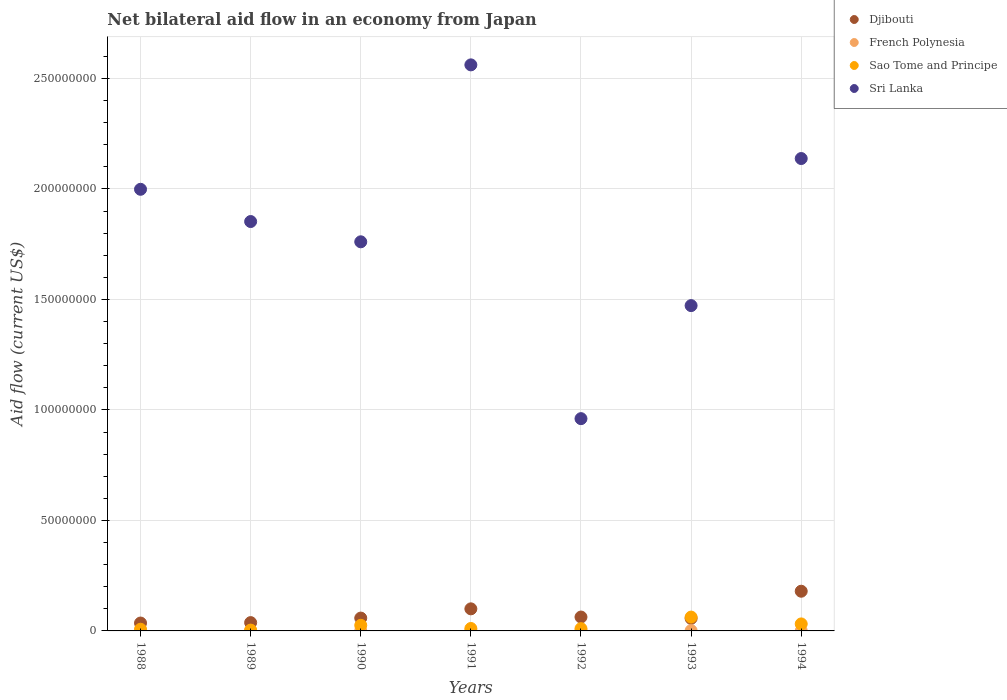Is the number of dotlines equal to the number of legend labels?
Provide a succinct answer. Yes. Across all years, what is the maximum net bilateral aid flow in Djibouti?
Give a very brief answer. 1.80e+07. Across all years, what is the minimum net bilateral aid flow in Sao Tome and Principe?
Offer a terse response. 3.70e+05. What is the total net bilateral aid flow in Sao Tome and Principe in the graph?
Keep it short and to the point. 1.52e+07. What is the difference between the net bilateral aid flow in Djibouti in 1989 and that in 1990?
Your answer should be very brief. -2.05e+06. What is the difference between the net bilateral aid flow in Djibouti in 1991 and the net bilateral aid flow in Sri Lanka in 1992?
Give a very brief answer. -8.61e+07. What is the average net bilateral aid flow in French Polynesia per year?
Keep it short and to the point. 1.13e+05. In the year 1988, what is the difference between the net bilateral aid flow in Sao Tome and Principe and net bilateral aid flow in French Polynesia?
Provide a short and direct response. 7.20e+05. In how many years, is the net bilateral aid flow in Sri Lanka greater than 160000000 US$?
Make the answer very short. 5. What is the ratio of the net bilateral aid flow in Sao Tome and Principe in 1988 to that in 1992?
Offer a terse response. 0.74. Is the difference between the net bilateral aid flow in Sao Tome and Principe in 1991 and 1994 greater than the difference between the net bilateral aid flow in French Polynesia in 1991 and 1994?
Offer a terse response. No. What is the difference between the highest and the second highest net bilateral aid flow in Sao Tome and Principe?
Provide a short and direct response. 3.09e+06. What is the difference between the highest and the lowest net bilateral aid flow in Djibouti?
Provide a succinct answer. 1.44e+07. Is it the case that in every year, the sum of the net bilateral aid flow in Sri Lanka and net bilateral aid flow in Sao Tome and Principe  is greater than the sum of net bilateral aid flow in Djibouti and net bilateral aid flow in French Polynesia?
Give a very brief answer. Yes. Is it the case that in every year, the sum of the net bilateral aid flow in Sri Lanka and net bilateral aid flow in French Polynesia  is greater than the net bilateral aid flow in Sao Tome and Principe?
Ensure brevity in your answer.  Yes. Is the net bilateral aid flow in Djibouti strictly greater than the net bilateral aid flow in French Polynesia over the years?
Give a very brief answer. Yes. How many dotlines are there?
Keep it short and to the point. 4. Are the values on the major ticks of Y-axis written in scientific E-notation?
Provide a short and direct response. No. Where does the legend appear in the graph?
Your answer should be very brief. Top right. How many legend labels are there?
Offer a very short reply. 4. What is the title of the graph?
Your response must be concise. Net bilateral aid flow in an economy from Japan. Does "Bulgaria" appear as one of the legend labels in the graph?
Offer a very short reply. No. What is the label or title of the Y-axis?
Your answer should be compact. Aid flow (current US$). What is the Aid flow (current US$) of Djibouti in 1988?
Ensure brevity in your answer.  3.57e+06. What is the Aid flow (current US$) in French Polynesia in 1988?
Make the answer very short. 4.00e+04. What is the Aid flow (current US$) of Sao Tome and Principe in 1988?
Your answer should be very brief. 7.60e+05. What is the Aid flow (current US$) of Sri Lanka in 1988?
Keep it short and to the point. 2.00e+08. What is the Aid flow (current US$) in Djibouti in 1989?
Keep it short and to the point. 3.76e+06. What is the Aid flow (current US$) in French Polynesia in 1989?
Give a very brief answer. 1.40e+05. What is the Aid flow (current US$) in Sao Tome and Principe in 1989?
Ensure brevity in your answer.  3.70e+05. What is the Aid flow (current US$) of Sri Lanka in 1989?
Your response must be concise. 1.85e+08. What is the Aid flow (current US$) of Djibouti in 1990?
Your answer should be compact. 5.81e+06. What is the Aid flow (current US$) in French Polynesia in 1990?
Keep it short and to the point. 1.00e+05. What is the Aid flow (current US$) in Sao Tome and Principe in 1990?
Keep it short and to the point. 2.54e+06. What is the Aid flow (current US$) of Sri Lanka in 1990?
Give a very brief answer. 1.76e+08. What is the Aid flow (current US$) in Djibouti in 1991?
Ensure brevity in your answer.  9.99e+06. What is the Aid flow (current US$) of French Polynesia in 1991?
Give a very brief answer. 1.40e+05. What is the Aid flow (current US$) of Sao Tome and Principe in 1991?
Your response must be concise. 1.10e+06. What is the Aid flow (current US$) in Sri Lanka in 1991?
Make the answer very short. 2.56e+08. What is the Aid flow (current US$) of Djibouti in 1992?
Keep it short and to the point. 6.28e+06. What is the Aid flow (current US$) in Sao Tome and Principe in 1992?
Offer a terse response. 1.03e+06. What is the Aid flow (current US$) in Sri Lanka in 1992?
Provide a succinct answer. 9.60e+07. What is the Aid flow (current US$) of Djibouti in 1993?
Give a very brief answer. 5.67e+06. What is the Aid flow (current US$) of French Polynesia in 1993?
Give a very brief answer. 1.40e+05. What is the Aid flow (current US$) in Sao Tome and Principe in 1993?
Provide a succinct answer. 6.26e+06. What is the Aid flow (current US$) of Sri Lanka in 1993?
Your response must be concise. 1.47e+08. What is the Aid flow (current US$) in Djibouti in 1994?
Give a very brief answer. 1.80e+07. What is the Aid flow (current US$) of Sao Tome and Principe in 1994?
Provide a succinct answer. 3.17e+06. What is the Aid flow (current US$) of Sri Lanka in 1994?
Provide a short and direct response. 2.14e+08. Across all years, what is the maximum Aid flow (current US$) in Djibouti?
Give a very brief answer. 1.80e+07. Across all years, what is the maximum Aid flow (current US$) of French Polynesia?
Ensure brevity in your answer.  1.70e+05. Across all years, what is the maximum Aid flow (current US$) of Sao Tome and Principe?
Your response must be concise. 6.26e+06. Across all years, what is the maximum Aid flow (current US$) in Sri Lanka?
Keep it short and to the point. 2.56e+08. Across all years, what is the minimum Aid flow (current US$) in Djibouti?
Offer a very short reply. 3.57e+06. Across all years, what is the minimum Aid flow (current US$) in French Polynesia?
Your response must be concise. 4.00e+04. Across all years, what is the minimum Aid flow (current US$) in Sao Tome and Principe?
Your response must be concise. 3.70e+05. Across all years, what is the minimum Aid flow (current US$) in Sri Lanka?
Your response must be concise. 9.60e+07. What is the total Aid flow (current US$) of Djibouti in the graph?
Your answer should be very brief. 5.30e+07. What is the total Aid flow (current US$) of French Polynesia in the graph?
Keep it short and to the point. 7.90e+05. What is the total Aid flow (current US$) in Sao Tome and Principe in the graph?
Offer a terse response. 1.52e+07. What is the total Aid flow (current US$) of Sri Lanka in the graph?
Offer a terse response. 1.27e+09. What is the difference between the Aid flow (current US$) of Djibouti in 1988 and that in 1989?
Ensure brevity in your answer.  -1.90e+05. What is the difference between the Aid flow (current US$) in Sri Lanka in 1988 and that in 1989?
Provide a short and direct response. 1.46e+07. What is the difference between the Aid flow (current US$) of Djibouti in 1988 and that in 1990?
Ensure brevity in your answer.  -2.24e+06. What is the difference between the Aid flow (current US$) of Sao Tome and Principe in 1988 and that in 1990?
Provide a short and direct response. -1.78e+06. What is the difference between the Aid flow (current US$) in Sri Lanka in 1988 and that in 1990?
Your answer should be compact. 2.38e+07. What is the difference between the Aid flow (current US$) in Djibouti in 1988 and that in 1991?
Offer a terse response. -6.42e+06. What is the difference between the Aid flow (current US$) of Sao Tome and Principe in 1988 and that in 1991?
Your answer should be compact. -3.40e+05. What is the difference between the Aid flow (current US$) of Sri Lanka in 1988 and that in 1991?
Your response must be concise. -5.63e+07. What is the difference between the Aid flow (current US$) in Djibouti in 1988 and that in 1992?
Provide a short and direct response. -2.71e+06. What is the difference between the Aid flow (current US$) in Sao Tome and Principe in 1988 and that in 1992?
Give a very brief answer. -2.70e+05. What is the difference between the Aid flow (current US$) of Sri Lanka in 1988 and that in 1992?
Your answer should be very brief. 1.04e+08. What is the difference between the Aid flow (current US$) of Djibouti in 1988 and that in 1993?
Provide a succinct answer. -2.10e+06. What is the difference between the Aid flow (current US$) in French Polynesia in 1988 and that in 1993?
Ensure brevity in your answer.  -1.00e+05. What is the difference between the Aid flow (current US$) in Sao Tome and Principe in 1988 and that in 1993?
Provide a succinct answer. -5.50e+06. What is the difference between the Aid flow (current US$) of Sri Lanka in 1988 and that in 1993?
Your answer should be compact. 5.26e+07. What is the difference between the Aid flow (current US$) of Djibouti in 1988 and that in 1994?
Your answer should be very brief. -1.44e+07. What is the difference between the Aid flow (current US$) in Sao Tome and Principe in 1988 and that in 1994?
Your response must be concise. -2.41e+06. What is the difference between the Aid flow (current US$) in Sri Lanka in 1988 and that in 1994?
Provide a succinct answer. -1.39e+07. What is the difference between the Aid flow (current US$) of Djibouti in 1989 and that in 1990?
Provide a short and direct response. -2.05e+06. What is the difference between the Aid flow (current US$) of French Polynesia in 1989 and that in 1990?
Make the answer very short. 4.00e+04. What is the difference between the Aid flow (current US$) in Sao Tome and Principe in 1989 and that in 1990?
Make the answer very short. -2.17e+06. What is the difference between the Aid flow (current US$) in Sri Lanka in 1989 and that in 1990?
Your answer should be very brief. 9.17e+06. What is the difference between the Aid flow (current US$) in Djibouti in 1989 and that in 1991?
Offer a very short reply. -6.23e+06. What is the difference between the Aid flow (current US$) in Sao Tome and Principe in 1989 and that in 1991?
Make the answer very short. -7.30e+05. What is the difference between the Aid flow (current US$) of Sri Lanka in 1989 and that in 1991?
Offer a terse response. -7.09e+07. What is the difference between the Aid flow (current US$) of Djibouti in 1989 and that in 1992?
Keep it short and to the point. -2.52e+06. What is the difference between the Aid flow (current US$) in Sao Tome and Principe in 1989 and that in 1992?
Keep it short and to the point. -6.60e+05. What is the difference between the Aid flow (current US$) in Sri Lanka in 1989 and that in 1992?
Keep it short and to the point. 8.92e+07. What is the difference between the Aid flow (current US$) of Djibouti in 1989 and that in 1993?
Offer a very short reply. -1.91e+06. What is the difference between the Aid flow (current US$) in French Polynesia in 1989 and that in 1993?
Make the answer very short. 0. What is the difference between the Aid flow (current US$) in Sao Tome and Principe in 1989 and that in 1993?
Ensure brevity in your answer.  -5.89e+06. What is the difference between the Aid flow (current US$) of Sri Lanka in 1989 and that in 1993?
Give a very brief answer. 3.80e+07. What is the difference between the Aid flow (current US$) of Djibouti in 1989 and that in 1994?
Your answer should be compact. -1.42e+07. What is the difference between the Aid flow (current US$) in Sao Tome and Principe in 1989 and that in 1994?
Keep it short and to the point. -2.80e+06. What is the difference between the Aid flow (current US$) of Sri Lanka in 1989 and that in 1994?
Ensure brevity in your answer.  -2.85e+07. What is the difference between the Aid flow (current US$) of Djibouti in 1990 and that in 1991?
Provide a succinct answer. -4.18e+06. What is the difference between the Aid flow (current US$) of Sao Tome and Principe in 1990 and that in 1991?
Your answer should be very brief. 1.44e+06. What is the difference between the Aid flow (current US$) in Sri Lanka in 1990 and that in 1991?
Your answer should be compact. -8.01e+07. What is the difference between the Aid flow (current US$) in Djibouti in 1990 and that in 1992?
Make the answer very short. -4.70e+05. What is the difference between the Aid flow (current US$) in French Polynesia in 1990 and that in 1992?
Provide a succinct answer. -7.00e+04. What is the difference between the Aid flow (current US$) of Sao Tome and Principe in 1990 and that in 1992?
Your response must be concise. 1.51e+06. What is the difference between the Aid flow (current US$) in Sri Lanka in 1990 and that in 1992?
Your answer should be compact. 8.00e+07. What is the difference between the Aid flow (current US$) in Djibouti in 1990 and that in 1993?
Give a very brief answer. 1.40e+05. What is the difference between the Aid flow (current US$) in Sao Tome and Principe in 1990 and that in 1993?
Your answer should be compact. -3.72e+06. What is the difference between the Aid flow (current US$) in Sri Lanka in 1990 and that in 1993?
Your answer should be very brief. 2.89e+07. What is the difference between the Aid flow (current US$) of Djibouti in 1990 and that in 1994?
Offer a very short reply. -1.22e+07. What is the difference between the Aid flow (current US$) of French Polynesia in 1990 and that in 1994?
Keep it short and to the point. 4.00e+04. What is the difference between the Aid flow (current US$) of Sao Tome and Principe in 1990 and that in 1994?
Offer a terse response. -6.30e+05. What is the difference between the Aid flow (current US$) of Sri Lanka in 1990 and that in 1994?
Offer a terse response. -3.77e+07. What is the difference between the Aid flow (current US$) in Djibouti in 1991 and that in 1992?
Your answer should be compact. 3.71e+06. What is the difference between the Aid flow (current US$) of French Polynesia in 1991 and that in 1992?
Ensure brevity in your answer.  -3.00e+04. What is the difference between the Aid flow (current US$) of Sao Tome and Principe in 1991 and that in 1992?
Ensure brevity in your answer.  7.00e+04. What is the difference between the Aid flow (current US$) of Sri Lanka in 1991 and that in 1992?
Your answer should be compact. 1.60e+08. What is the difference between the Aid flow (current US$) in Djibouti in 1991 and that in 1993?
Keep it short and to the point. 4.32e+06. What is the difference between the Aid flow (current US$) of Sao Tome and Principe in 1991 and that in 1993?
Make the answer very short. -5.16e+06. What is the difference between the Aid flow (current US$) of Sri Lanka in 1991 and that in 1993?
Make the answer very short. 1.09e+08. What is the difference between the Aid flow (current US$) in Djibouti in 1991 and that in 1994?
Keep it short and to the point. -7.97e+06. What is the difference between the Aid flow (current US$) of Sao Tome and Principe in 1991 and that in 1994?
Your answer should be compact. -2.07e+06. What is the difference between the Aid flow (current US$) in Sri Lanka in 1991 and that in 1994?
Your answer should be very brief. 4.24e+07. What is the difference between the Aid flow (current US$) of Djibouti in 1992 and that in 1993?
Keep it short and to the point. 6.10e+05. What is the difference between the Aid flow (current US$) in Sao Tome and Principe in 1992 and that in 1993?
Offer a very short reply. -5.23e+06. What is the difference between the Aid flow (current US$) of Sri Lanka in 1992 and that in 1993?
Ensure brevity in your answer.  -5.12e+07. What is the difference between the Aid flow (current US$) of Djibouti in 1992 and that in 1994?
Your response must be concise. -1.17e+07. What is the difference between the Aid flow (current US$) of Sao Tome and Principe in 1992 and that in 1994?
Keep it short and to the point. -2.14e+06. What is the difference between the Aid flow (current US$) in Sri Lanka in 1992 and that in 1994?
Give a very brief answer. -1.18e+08. What is the difference between the Aid flow (current US$) in Djibouti in 1993 and that in 1994?
Give a very brief answer. -1.23e+07. What is the difference between the Aid flow (current US$) of French Polynesia in 1993 and that in 1994?
Ensure brevity in your answer.  8.00e+04. What is the difference between the Aid flow (current US$) in Sao Tome and Principe in 1993 and that in 1994?
Keep it short and to the point. 3.09e+06. What is the difference between the Aid flow (current US$) of Sri Lanka in 1993 and that in 1994?
Provide a short and direct response. -6.66e+07. What is the difference between the Aid flow (current US$) in Djibouti in 1988 and the Aid flow (current US$) in French Polynesia in 1989?
Ensure brevity in your answer.  3.43e+06. What is the difference between the Aid flow (current US$) of Djibouti in 1988 and the Aid flow (current US$) of Sao Tome and Principe in 1989?
Provide a succinct answer. 3.20e+06. What is the difference between the Aid flow (current US$) of Djibouti in 1988 and the Aid flow (current US$) of Sri Lanka in 1989?
Make the answer very short. -1.82e+08. What is the difference between the Aid flow (current US$) in French Polynesia in 1988 and the Aid flow (current US$) in Sao Tome and Principe in 1989?
Ensure brevity in your answer.  -3.30e+05. What is the difference between the Aid flow (current US$) of French Polynesia in 1988 and the Aid flow (current US$) of Sri Lanka in 1989?
Offer a terse response. -1.85e+08. What is the difference between the Aid flow (current US$) of Sao Tome and Principe in 1988 and the Aid flow (current US$) of Sri Lanka in 1989?
Offer a very short reply. -1.84e+08. What is the difference between the Aid flow (current US$) in Djibouti in 1988 and the Aid flow (current US$) in French Polynesia in 1990?
Offer a terse response. 3.47e+06. What is the difference between the Aid flow (current US$) in Djibouti in 1988 and the Aid flow (current US$) in Sao Tome and Principe in 1990?
Provide a short and direct response. 1.03e+06. What is the difference between the Aid flow (current US$) in Djibouti in 1988 and the Aid flow (current US$) in Sri Lanka in 1990?
Your answer should be very brief. -1.72e+08. What is the difference between the Aid flow (current US$) in French Polynesia in 1988 and the Aid flow (current US$) in Sao Tome and Principe in 1990?
Offer a very short reply. -2.50e+06. What is the difference between the Aid flow (current US$) of French Polynesia in 1988 and the Aid flow (current US$) of Sri Lanka in 1990?
Your answer should be compact. -1.76e+08. What is the difference between the Aid flow (current US$) in Sao Tome and Principe in 1988 and the Aid flow (current US$) in Sri Lanka in 1990?
Offer a very short reply. -1.75e+08. What is the difference between the Aid flow (current US$) of Djibouti in 1988 and the Aid flow (current US$) of French Polynesia in 1991?
Give a very brief answer. 3.43e+06. What is the difference between the Aid flow (current US$) in Djibouti in 1988 and the Aid flow (current US$) in Sao Tome and Principe in 1991?
Offer a terse response. 2.47e+06. What is the difference between the Aid flow (current US$) of Djibouti in 1988 and the Aid flow (current US$) of Sri Lanka in 1991?
Give a very brief answer. -2.53e+08. What is the difference between the Aid flow (current US$) of French Polynesia in 1988 and the Aid flow (current US$) of Sao Tome and Principe in 1991?
Your response must be concise. -1.06e+06. What is the difference between the Aid flow (current US$) in French Polynesia in 1988 and the Aid flow (current US$) in Sri Lanka in 1991?
Ensure brevity in your answer.  -2.56e+08. What is the difference between the Aid flow (current US$) of Sao Tome and Principe in 1988 and the Aid flow (current US$) of Sri Lanka in 1991?
Your response must be concise. -2.55e+08. What is the difference between the Aid flow (current US$) in Djibouti in 1988 and the Aid flow (current US$) in French Polynesia in 1992?
Ensure brevity in your answer.  3.40e+06. What is the difference between the Aid flow (current US$) of Djibouti in 1988 and the Aid flow (current US$) of Sao Tome and Principe in 1992?
Give a very brief answer. 2.54e+06. What is the difference between the Aid flow (current US$) of Djibouti in 1988 and the Aid flow (current US$) of Sri Lanka in 1992?
Provide a succinct answer. -9.25e+07. What is the difference between the Aid flow (current US$) of French Polynesia in 1988 and the Aid flow (current US$) of Sao Tome and Principe in 1992?
Offer a terse response. -9.90e+05. What is the difference between the Aid flow (current US$) in French Polynesia in 1988 and the Aid flow (current US$) in Sri Lanka in 1992?
Your response must be concise. -9.60e+07. What is the difference between the Aid flow (current US$) of Sao Tome and Principe in 1988 and the Aid flow (current US$) of Sri Lanka in 1992?
Your answer should be compact. -9.53e+07. What is the difference between the Aid flow (current US$) in Djibouti in 1988 and the Aid flow (current US$) in French Polynesia in 1993?
Make the answer very short. 3.43e+06. What is the difference between the Aid flow (current US$) in Djibouti in 1988 and the Aid flow (current US$) in Sao Tome and Principe in 1993?
Give a very brief answer. -2.69e+06. What is the difference between the Aid flow (current US$) in Djibouti in 1988 and the Aid flow (current US$) in Sri Lanka in 1993?
Provide a short and direct response. -1.44e+08. What is the difference between the Aid flow (current US$) of French Polynesia in 1988 and the Aid flow (current US$) of Sao Tome and Principe in 1993?
Your response must be concise. -6.22e+06. What is the difference between the Aid flow (current US$) in French Polynesia in 1988 and the Aid flow (current US$) in Sri Lanka in 1993?
Offer a terse response. -1.47e+08. What is the difference between the Aid flow (current US$) in Sao Tome and Principe in 1988 and the Aid flow (current US$) in Sri Lanka in 1993?
Offer a very short reply. -1.46e+08. What is the difference between the Aid flow (current US$) of Djibouti in 1988 and the Aid flow (current US$) of French Polynesia in 1994?
Keep it short and to the point. 3.51e+06. What is the difference between the Aid flow (current US$) in Djibouti in 1988 and the Aid flow (current US$) in Sri Lanka in 1994?
Your answer should be very brief. -2.10e+08. What is the difference between the Aid flow (current US$) of French Polynesia in 1988 and the Aid flow (current US$) of Sao Tome and Principe in 1994?
Provide a succinct answer. -3.13e+06. What is the difference between the Aid flow (current US$) in French Polynesia in 1988 and the Aid flow (current US$) in Sri Lanka in 1994?
Your answer should be very brief. -2.14e+08. What is the difference between the Aid flow (current US$) in Sao Tome and Principe in 1988 and the Aid flow (current US$) in Sri Lanka in 1994?
Your response must be concise. -2.13e+08. What is the difference between the Aid flow (current US$) in Djibouti in 1989 and the Aid flow (current US$) in French Polynesia in 1990?
Offer a terse response. 3.66e+06. What is the difference between the Aid flow (current US$) in Djibouti in 1989 and the Aid flow (current US$) in Sao Tome and Principe in 1990?
Give a very brief answer. 1.22e+06. What is the difference between the Aid flow (current US$) in Djibouti in 1989 and the Aid flow (current US$) in Sri Lanka in 1990?
Keep it short and to the point. -1.72e+08. What is the difference between the Aid flow (current US$) of French Polynesia in 1989 and the Aid flow (current US$) of Sao Tome and Principe in 1990?
Provide a succinct answer. -2.40e+06. What is the difference between the Aid flow (current US$) of French Polynesia in 1989 and the Aid flow (current US$) of Sri Lanka in 1990?
Provide a short and direct response. -1.76e+08. What is the difference between the Aid flow (current US$) of Sao Tome and Principe in 1989 and the Aid flow (current US$) of Sri Lanka in 1990?
Your response must be concise. -1.76e+08. What is the difference between the Aid flow (current US$) in Djibouti in 1989 and the Aid flow (current US$) in French Polynesia in 1991?
Offer a very short reply. 3.62e+06. What is the difference between the Aid flow (current US$) in Djibouti in 1989 and the Aid flow (current US$) in Sao Tome and Principe in 1991?
Give a very brief answer. 2.66e+06. What is the difference between the Aid flow (current US$) in Djibouti in 1989 and the Aid flow (current US$) in Sri Lanka in 1991?
Ensure brevity in your answer.  -2.52e+08. What is the difference between the Aid flow (current US$) of French Polynesia in 1989 and the Aid flow (current US$) of Sao Tome and Principe in 1991?
Your answer should be very brief. -9.60e+05. What is the difference between the Aid flow (current US$) in French Polynesia in 1989 and the Aid flow (current US$) in Sri Lanka in 1991?
Ensure brevity in your answer.  -2.56e+08. What is the difference between the Aid flow (current US$) of Sao Tome and Principe in 1989 and the Aid flow (current US$) of Sri Lanka in 1991?
Make the answer very short. -2.56e+08. What is the difference between the Aid flow (current US$) in Djibouti in 1989 and the Aid flow (current US$) in French Polynesia in 1992?
Your answer should be very brief. 3.59e+06. What is the difference between the Aid flow (current US$) of Djibouti in 1989 and the Aid flow (current US$) of Sao Tome and Principe in 1992?
Ensure brevity in your answer.  2.73e+06. What is the difference between the Aid flow (current US$) of Djibouti in 1989 and the Aid flow (current US$) of Sri Lanka in 1992?
Give a very brief answer. -9.23e+07. What is the difference between the Aid flow (current US$) in French Polynesia in 1989 and the Aid flow (current US$) in Sao Tome and Principe in 1992?
Provide a succinct answer. -8.90e+05. What is the difference between the Aid flow (current US$) in French Polynesia in 1989 and the Aid flow (current US$) in Sri Lanka in 1992?
Keep it short and to the point. -9.59e+07. What is the difference between the Aid flow (current US$) of Sao Tome and Principe in 1989 and the Aid flow (current US$) of Sri Lanka in 1992?
Give a very brief answer. -9.57e+07. What is the difference between the Aid flow (current US$) in Djibouti in 1989 and the Aid flow (current US$) in French Polynesia in 1993?
Keep it short and to the point. 3.62e+06. What is the difference between the Aid flow (current US$) of Djibouti in 1989 and the Aid flow (current US$) of Sao Tome and Principe in 1993?
Make the answer very short. -2.50e+06. What is the difference between the Aid flow (current US$) in Djibouti in 1989 and the Aid flow (current US$) in Sri Lanka in 1993?
Ensure brevity in your answer.  -1.43e+08. What is the difference between the Aid flow (current US$) of French Polynesia in 1989 and the Aid flow (current US$) of Sao Tome and Principe in 1993?
Ensure brevity in your answer.  -6.12e+06. What is the difference between the Aid flow (current US$) of French Polynesia in 1989 and the Aid flow (current US$) of Sri Lanka in 1993?
Provide a succinct answer. -1.47e+08. What is the difference between the Aid flow (current US$) of Sao Tome and Principe in 1989 and the Aid flow (current US$) of Sri Lanka in 1993?
Provide a short and direct response. -1.47e+08. What is the difference between the Aid flow (current US$) of Djibouti in 1989 and the Aid flow (current US$) of French Polynesia in 1994?
Give a very brief answer. 3.70e+06. What is the difference between the Aid flow (current US$) of Djibouti in 1989 and the Aid flow (current US$) of Sao Tome and Principe in 1994?
Your response must be concise. 5.90e+05. What is the difference between the Aid flow (current US$) of Djibouti in 1989 and the Aid flow (current US$) of Sri Lanka in 1994?
Offer a terse response. -2.10e+08. What is the difference between the Aid flow (current US$) of French Polynesia in 1989 and the Aid flow (current US$) of Sao Tome and Principe in 1994?
Your answer should be compact. -3.03e+06. What is the difference between the Aid flow (current US$) of French Polynesia in 1989 and the Aid flow (current US$) of Sri Lanka in 1994?
Ensure brevity in your answer.  -2.14e+08. What is the difference between the Aid flow (current US$) in Sao Tome and Principe in 1989 and the Aid flow (current US$) in Sri Lanka in 1994?
Provide a short and direct response. -2.13e+08. What is the difference between the Aid flow (current US$) in Djibouti in 1990 and the Aid flow (current US$) in French Polynesia in 1991?
Give a very brief answer. 5.67e+06. What is the difference between the Aid flow (current US$) of Djibouti in 1990 and the Aid flow (current US$) of Sao Tome and Principe in 1991?
Offer a very short reply. 4.71e+06. What is the difference between the Aid flow (current US$) in Djibouti in 1990 and the Aid flow (current US$) in Sri Lanka in 1991?
Your answer should be very brief. -2.50e+08. What is the difference between the Aid flow (current US$) of French Polynesia in 1990 and the Aid flow (current US$) of Sao Tome and Principe in 1991?
Ensure brevity in your answer.  -1.00e+06. What is the difference between the Aid flow (current US$) in French Polynesia in 1990 and the Aid flow (current US$) in Sri Lanka in 1991?
Offer a very short reply. -2.56e+08. What is the difference between the Aid flow (current US$) in Sao Tome and Principe in 1990 and the Aid flow (current US$) in Sri Lanka in 1991?
Your answer should be compact. -2.54e+08. What is the difference between the Aid flow (current US$) of Djibouti in 1990 and the Aid flow (current US$) of French Polynesia in 1992?
Make the answer very short. 5.64e+06. What is the difference between the Aid flow (current US$) in Djibouti in 1990 and the Aid flow (current US$) in Sao Tome and Principe in 1992?
Your answer should be compact. 4.78e+06. What is the difference between the Aid flow (current US$) of Djibouti in 1990 and the Aid flow (current US$) of Sri Lanka in 1992?
Offer a terse response. -9.02e+07. What is the difference between the Aid flow (current US$) in French Polynesia in 1990 and the Aid flow (current US$) in Sao Tome and Principe in 1992?
Ensure brevity in your answer.  -9.30e+05. What is the difference between the Aid flow (current US$) of French Polynesia in 1990 and the Aid flow (current US$) of Sri Lanka in 1992?
Make the answer very short. -9.60e+07. What is the difference between the Aid flow (current US$) of Sao Tome and Principe in 1990 and the Aid flow (current US$) of Sri Lanka in 1992?
Your answer should be compact. -9.35e+07. What is the difference between the Aid flow (current US$) in Djibouti in 1990 and the Aid flow (current US$) in French Polynesia in 1993?
Offer a terse response. 5.67e+06. What is the difference between the Aid flow (current US$) in Djibouti in 1990 and the Aid flow (current US$) in Sao Tome and Principe in 1993?
Provide a short and direct response. -4.50e+05. What is the difference between the Aid flow (current US$) of Djibouti in 1990 and the Aid flow (current US$) of Sri Lanka in 1993?
Provide a succinct answer. -1.41e+08. What is the difference between the Aid flow (current US$) of French Polynesia in 1990 and the Aid flow (current US$) of Sao Tome and Principe in 1993?
Your response must be concise. -6.16e+06. What is the difference between the Aid flow (current US$) in French Polynesia in 1990 and the Aid flow (current US$) in Sri Lanka in 1993?
Give a very brief answer. -1.47e+08. What is the difference between the Aid flow (current US$) in Sao Tome and Principe in 1990 and the Aid flow (current US$) in Sri Lanka in 1993?
Offer a terse response. -1.45e+08. What is the difference between the Aid flow (current US$) of Djibouti in 1990 and the Aid flow (current US$) of French Polynesia in 1994?
Your answer should be very brief. 5.75e+06. What is the difference between the Aid flow (current US$) in Djibouti in 1990 and the Aid flow (current US$) in Sao Tome and Principe in 1994?
Keep it short and to the point. 2.64e+06. What is the difference between the Aid flow (current US$) of Djibouti in 1990 and the Aid flow (current US$) of Sri Lanka in 1994?
Make the answer very short. -2.08e+08. What is the difference between the Aid flow (current US$) in French Polynesia in 1990 and the Aid flow (current US$) in Sao Tome and Principe in 1994?
Keep it short and to the point. -3.07e+06. What is the difference between the Aid flow (current US$) of French Polynesia in 1990 and the Aid flow (current US$) of Sri Lanka in 1994?
Provide a succinct answer. -2.14e+08. What is the difference between the Aid flow (current US$) in Sao Tome and Principe in 1990 and the Aid flow (current US$) in Sri Lanka in 1994?
Keep it short and to the point. -2.11e+08. What is the difference between the Aid flow (current US$) of Djibouti in 1991 and the Aid flow (current US$) of French Polynesia in 1992?
Keep it short and to the point. 9.82e+06. What is the difference between the Aid flow (current US$) in Djibouti in 1991 and the Aid flow (current US$) in Sao Tome and Principe in 1992?
Provide a succinct answer. 8.96e+06. What is the difference between the Aid flow (current US$) in Djibouti in 1991 and the Aid flow (current US$) in Sri Lanka in 1992?
Provide a succinct answer. -8.61e+07. What is the difference between the Aid flow (current US$) in French Polynesia in 1991 and the Aid flow (current US$) in Sao Tome and Principe in 1992?
Provide a succinct answer. -8.90e+05. What is the difference between the Aid flow (current US$) in French Polynesia in 1991 and the Aid flow (current US$) in Sri Lanka in 1992?
Offer a very short reply. -9.59e+07. What is the difference between the Aid flow (current US$) in Sao Tome and Principe in 1991 and the Aid flow (current US$) in Sri Lanka in 1992?
Keep it short and to the point. -9.50e+07. What is the difference between the Aid flow (current US$) of Djibouti in 1991 and the Aid flow (current US$) of French Polynesia in 1993?
Provide a short and direct response. 9.85e+06. What is the difference between the Aid flow (current US$) of Djibouti in 1991 and the Aid flow (current US$) of Sao Tome and Principe in 1993?
Ensure brevity in your answer.  3.73e+06. What is the difference between the Aid flow (current US$) of Djibouti in 1991 and the Aid flow (current US$) of Sri Lanka in 1993?
Offer a very short reply. -1.37e+08. What is the difference between the Aid flow (current US$) of French Polynesia in 1991 and the Aid flow (current US$) of Sao Tome and Principe in 1993?
Your answer should be very brief. -6.12e+06. What is the difference between the Aid flow (current US$) of French Polynesia in 1991 and the Aid flow (current US$) of Sri Lanka in 1993?
Your answer should be very brief. -1.47e+08. What is the difference between the Aid flow (current US$) in Sao Tome and Principe in 1991 and the Aid flow (current US$) in Sri Lanka in 1993?
Provide a short and direct response. -1.46e+08. What is the difference between the Aid flow (current US$) in Djibouti in 1991 and the Aid flow (current US$) in French Polynesia in 1994?
Ensure brevity in your answer.  9.93e+06. What is the difference between the Aid flow (current US$) of Djibouti in 1991 and the Aid flow (current US$) of Sao Tome and Principe in 1994?
Your response must be concise. 6.82e+06. What is the difference between the Aid flow (current US$) of Djibouti in 1991 and the Aid flow (current US$) of Sri Lanka in 1994?
Ensure brevity in your answer.  -2.04e+08. What is the difference between the Aid flow (current US$) in French Polynesia in 1991 and the Aid flow (current US$) in Sao Tome and Principe in 1994?
Offer a terse response. -3.03e+06. What is the difference between the Aid flow (current US$) in French Polynesia in 1991 and the Aid flow (current US$) in Sri Lanka in 1994?
Make the answer very short. -2.14e+08. What is the difference between the Aid flow (current US$) of Sao Tome and Principe in 1991 and the Aid flow (current US$) of Sri Lanka in 1994?
Provide a short and direct response. -2.13e+08. What is the difference between the Aid flow (current US$) of Djibouti in 1992 and the Aid flow (current US$) of French Polynesia in 1993?
Provide a succinct answer. 6.14e+06. What is the difference between the Aid flow (current US$) of Djibouti in 1992 and the Aid flow (current US$) of Sao Tome and Principe in 1993?
Your response must be concise. 2.00e+04. What is the difference between the Aid flow (current US$) of Djibouti in 1992 and the Aid flow (current US$) of Sri Lanka in 1993?
Keep it short and to the point. -1.41e+08. What is the difference between the Aid flow (current US$) in French Polynesia in 1992 and the Aid flow (current US$) in Sao Tome and Principe in 1993?
Provide a short and direct response. -6.09e+06. What is the difference between the Aid flow (current US$) of French Polynesia in 1992 and the Aid flow (current US$) of Sri Lanka in 1993?
Give a very brief answer. -1.47e+08. What is the difference between the Aid flow (current US$) in Sao Tome and Principe in 1992 and the Aid flow (current US$) in Sri Lanka in 1993?
Ensure brevity in your answer.  -1.46e+08. What is the difference between the Aid flow (current US$) in Djibouti in 1992 and the Aid flow (current US$) in French Polynesia in 1994?
Your response must be concise. 6.22e+06. What is the difference between the Aid flow (current US$) of Djibouti in 1992 and the Aid flow (current US$) of Sao Tome and Principe in 1994?
Your answer should be compact. 3.11e+06. What is the difference between the Aid flow (current US$) in Djibouti in 1992 and the Aid flow (current US$) in Sri Lanka in 1994?
Your response must be concise. -2.07e+08. What is the difference between the Aid flow (current US$) in French Polynesia in 1992 and the Aid flow (current US$) in Sao Tome and Principe in 1994?
Give a very brief answer. -3.00e+06. What is the difference between the Aid flow (current US$) in French Polynesia in 1992 and the Aid flow (current US$) in Sri Lanka in 1994?
Provide a succinct answer. -2.14e+08. What is the difference between the Aid flow (current US$) in Sao Tome and Principe in 1992 and the Aid flow (current US$) in Sri Lanka in 1994?
Give a very brief answer. -2.13e+08. What is the difference between the Aid flow (current US$) in Djibouti in 1993 and the Aid flow (current US$) in French Polynesia in 1994?
Your response must be concise. 5.61e+06. What is the difference between the Aid flow (current US$) in Djibouti in 1993 and the Aid flow (current US$) in Sao Tome and Principe in 1994?
Your response must be concise. 2.50e+06. What is the difference between the Aid flow (current US$) of Djibouti in 1993 and the Aid flow (current US$) of Sri Lanka in 1994?
Offer a terse response. -2.08e+08. What is the difference between the Aid flow (current US$) of French Polynesia in 1993 and the Aid flow (current US$) of Sao Tome and Principe in 1994?
Your answer should be very brief. -3.03e+06. What is the difference between the Aid flow (current US$) in French Polynesia in 1993 and the Aid flow (current US$) in Sri Lanka in 1994?
Provide a succinct answer. -2.14e+08. What is the difference between the Aid flow (current US$) in Sao Tome and Principe in 1993 and the Aid flow (current US$) in Sri Lanka in 1994?
Your response must be concise. -2.07e+08. What is the average Aid flow (current US$) of Djibouti per year?
Your response must be concise. 7.58e+06. What is the average Aid flow (current US$) in French Polynesia per year?
Your answer should be very brief. 1.13e+05. What is the average Aid flow (current US$) in Sao Tome and Principe per year?
Offer a terse response. 2.18e+06. What is the average Aid flow (current US$) of Sri Lanka per year?
Provide a succinct answer. 1.82e+08. In the year 1988, what is the difference between the Aid flow (current US$) in Djibouti and Aid flow (current US$) in French Polynesia?
Offer a very short reply. 3.53e+06. In the year 1988, what is the difference between the Aid flow (current US$) in Djibouti and Aid flow (current US$) in Sao Tome and Principe?
Offer a terse response. 2.81e+06. In the year 1988, what is the difference between the Aid flow (current US$) in Djibouti and Aid flow (current US$) in Sri Lanka?
Offer a terse response. -1.96e+08. In the year 1988, what is the difference between the Aid flow (current US$) in French Polynesia and Aid flow (current US$) in Sao Tome and Principe?
Provide a succinct answer. -7.20e+05. In the year 1988, what is the difference between the Aid flow (current US$) in French Polynesia and Aid flow (current US$) in Sri Lanka?
Your response must be concise. -2.00e+08. In the year 1988, what is the difference between the Aid flow (current US$) of Sao Tome and Principe and Aid flow (current US$) of Sri Lanka?
Provide a short and direct response. -1.99e+08. In the year 1989, what is the difference between the Aid flow (current US$) of Djibouti and Aid flow (current US$) of French Polynesia?
Offer a very short reply. 3.62e+06. In the year 1989, what is the difference between the Aid flow (current US$) in Djibouti and Aid flow (current US$) in Sao Tome and Principe?
Keep it short and to the point. 3.39e+06. In the year 1989, what is the difference between the Aid flow (current US$) of Djibouti and Aid flow (current US$) of Sri Lanka?
Offer a very short reply. -1.81e+08. In the year 1989, what is the difference between the Aid flow (current US$) in French Polynesia and Aid flow (current US$) in Sao Tome and Principe?
Provide a succinct answer. -2.30e+05. In the year 1989, what is the difference between the Aid flow (current US$) of French Polynesia and Aid flow (current US$) of Sri Lanka?
Your response must be concise. -1.85e+08. In the year 1989, what is the difference between the Aid flow (current US$) of Sao Tome and Principe and Aid flow (current US$) of Sri Lanka?
Provide a succinct answer. -1.85e+08. In the year 1990, what is the difference between the Aid flow (current US$) of Djibouti and Aid flow (current US$) of French Polynesia?
Ensure brevity in your answer.  5.71e+06. In the year 1990, what is the difference between the Aid flow (current US$) in Djibouti and Aid flow (current US$) in Sao Tome and Principe?
Your response must be concise. 3.27e+06. In the year 1990, what is the difference between the Aid flow (current US$) of Djibouti and Aid flow (current US$) of Sri Lanka?
Give a very brief answer. -1.70e+08. In the year 1990, what is the difference between the Aid flow (current US$) of French Polynesia and Aid flow (current US$) of Sao Tome and Principe?
Your answer should be very brief. -2.44e+06. In the year 1990, what is the difference between the Aid flow (current US$) of French Polynesia and Aid flow (current US$) of Sri Lanka?
Your answer should be compact. -1.76e+08. In the year 1990, what is the difference between the Aid flow (current US$) in Sao Tome and Principe and Aid flow (current US$) in Sri Lanka?
Ensure brevity in your answer.  -1.74e+08. In the year 1991, what is the difference between the Aid flow (current US$) of Djibouti and Aid flow (current US$) of French Polynesia?
Keep it short and to the point. 9.85e+06. In the year 1991, what is the difference between the Aid flow (current US$) of Djibouti and Aid flow (current US$) of Sao Tome and Principe?
Offer a very short reply. 8.89e+06. In the year 1991, what is the difference between the Aid flow (current US$) in Djibouti and Aid flow (current US$) in Sri Lanka?
Provide a succinct answer. -2.46e+08. In the year 1991, what is the difference between the Aid flow (current US$) in French Polynesia and Aid flow (current US$) in Sao Tome and Principe?
Provide a succinct answer. -9.60e+05. In the year 1991, what is the difference between the Aid flow (current US$) of French Polynesia and Aid flow (current US$) of Sri Lanka?
Make the answer very short. -2.56e+08. In the year 1991, what is the difference between the Aid flow (current US$) in Sao Tome and Principe and Aid flow (current US$) in Sri Lanka?
Provide a short and direct response. -2.55e+08. In the year 1992, what is the difference between the Aid flow (current US$) of Djibouti and Aid flow (current US$) of French Polynesia?
Provide a succinct answer. 6.11e+06. In the year 1992, what is the difference between the Aid flow (current US$) of Djibouti and Aid flow (current US$) of Sao Tome and Principe?
Ensure brevity in your answer.  5.25e+06. In the year 1992, what is the difference between the Aid flow (current US$) in Djibouti and Aid flow (current US$) in Sri Lanka?
Provide a succinct answer. -8.98e+07. In the year 1992, what is the difference between the Aid flow (current US$) in French Polynesia and Aid flow (current US$) in Sao Tome and Principe?
Keep it short and to the point. -8.60e+05. In the year 1992, what is the difference between the Aid flow (current US$) in French Polynesia and Aid flow (current US$) in Sri Lanka?
Your answer should be very brief. -9.59e+07. In the year 1992, what is the difference between the Aid flow (current US$) of Sao Tome and Principe and Aid flow (current US$) of Sri Lanka?
Provide a short and direct response. -9.50e+07. In the year 1993, what is the difference between the Aid flow (current US$) in Djibouti and Aid flow (current US$) in French Polynesia?
Provide a succinct answer. 5.53e+06. In the year 1993, what is the difference between the Aid flow (current US$) in Djibouti and Aid flow (current US$) in Sao Tome and Principe?
Provide a succinct answer. -5.90e+05. In the year 1993, what is the difference between the Aid flow (current US$) in Djibouti and Aid flow (current US$) in Sri Lanka?
Provide a succinct answer. -1.42e+08. In the year 1993, what is the difference between the Aid flow (current US$) in French Polynesia and Aid flow (current US$) in Sao Tome and Principe?
Provide a succinct answer. -6.12e+06. In the year 1993, what is the difference between the Aid flow (current US$) of French Polynesia and Aid flow (current US$) of Sri Lanka?
Give a very brief answer. -1.47e+08. In the year 1993, what is the difference between the Aid flow (current US$) of Sao Tome and Principe and Aid flow (current US$) of Sri Lanka?
Keep it short and to the point. -1.41e+08. In the year 1994, what is the difference between the Aid flow (current US$) in Djibouti and Aid flow (current US$) in French Polynesia?
Offer a very short reply. 1.79e+07. In the year 1994, what is the difference between the Aid flow (current US$) of Djibouti and Aid flow (current US$) of Sao Tome and Principe?
Your answer should be compact. 1.48e+07. In the year 1994, what is the difference between the Aid flow (current US$) in Djibouti and Aid flow (current US$) in Sri Lanka?
Keep it short and to the point. -1.96e+08. In the year 1994, what is the difference between the Aid flow (current US$) in French Polynesia and Aid flow (current US$) in Sao Tome and Principe?
Keep it short and to the point. -3.11e+06. In the year 1994, what is the difference between the Aid flow (current US$) in French Polynesia and Aid flow (current US$) in Sri Lanka?
Your answer should be compact. -2.14e+08. In the year 1994, what is the difference between the Aid flow (current US$) in Sao Tome and Principe and Aid flow (current US$) in Sri Lanka?
Provide a succinct answer. -2.11e+08. What is the ratio of the Aid flow (current US$) of Djibouti in 1988 to that in 1989?
Make the answer very short. 0.95. What is the ratio of the Aid flow (current US$) of French Polynesia in 1988 to that in 1989?
Give a very brief answer. 0.29. What is the ratio of the Aid flow (current US$) in Sao Tome and Principe in 1988 to that in 1989?
Offer a very short reply. 2.05. What is the ratio of the Aid flow (current US$) of Sri Lanka in 1988 to that in 1989?
Provide a short and direct response. 1.08. What is the ratio of the Aid flow (current US$) of Djibouti in 1988 to that in 1990?
Provide a short and direct response. 0.61. What is the ratio of the Aid flow (current US$) in Sao Tome and Principe in 1988 to that in 1990?
Your response must be concise. 0.3. What is the ratio of the Aid flow (current US$) in Sri Lanka in 1988 to that in 1990?
Ensure brevity in your answer.  1.13. What is the ratio of the Aid flow (current US$) of Djibouti in 1988 to that in 1991?
Your answer should be compact. 0.36. What is the ratio of the Aid flow (current US$) in French Polynesia in 1988 to that in 1991?
Provide a succinct answer. 0.29. What is the ratio of the Aid flow (current US$) in Sao Tome and Principe in 1988 to that in 1991?
Offer a terse response. 0.69. What is the ratio of the Aid flow (current US$) in Sri Lanka in 1988 to that in 1991?
Your response must be concise. 0.78. What is the ratio of the Aid flow (current US$) in Djibouti in 1988 to that in 1992?
Your answer should be very brief. 0.57. What is the ratio of the Aid flow (current US$) in French Polynesia in 1988 to that in 1992?
Keep it short and to the point. 0.24. What is the ratio of the Aid flow (current US$) in Sao Tome and Principe in 1988 to that in 1992?
Provide a short and direct response. 0.74. What is the ratio of the Aid flow (current US$) in Sri Lanka in 1988 to that in 1992?
Your answer should be very brief. 2.08. What is the ratio of the Aid flow (current US$) in Djibouti in 1988 to that in 1993?
Your response must be concise. 0.63. What is the ratio of the Aid flow (current US$) in French Polynesia in 1988 to that in 1993?
Your answer should be very brief. 0.29. What is the ratio of the Aid flow (current US$) in Sao Tome and Principe in 1988 to that in 1993?
Offer a very short reply. 0.12. What is the ratio of the Aid flow (current US$) in Sri Lanka in 1988 to that in 1993?
Your answer should be very brief. 1.36. What is the ratio of the Aid flow (current US$) in Djibouti in 1988 to that in 1994?
Offer a very short reply. 0.2. What is the ratio of the Aid flow (current US$) in Sao Tome and Principe in 1988 to that in 1994?
Your answer should be very brief. 0.24. What is the ratio of the Aid flow (current US$) of Sri Lanka in 1988 to that in 1994?
Your answer should be compact. 0.93. What is the ratio of the Aid flow (current US$) in Djibouti in 1989 to that in 1990?
Offer a terse response. 0.65. What is the ratio of the Aid flow (current US$) in French Polynesia in 1989 to that in 1990?
Your answer should be compact. 1.4. What is the ratio of the Aid flow (current US$) in Sao Tome and Principe in 1989 to that in 1990?
Make the answer very short. 0.15. What is the ratio of the Aid flow (current US$) in Sri Lanka in 1989 to that in 1990?
Your answer should be very brief. 1.05. What is the ratio of the Aid flow (current US$) in Djibouti in 1989 to that in 1991?
Offer a terse response. 0.38. What is the ratio of the Aid flow (current US$) of French Polynesia in 1989 to that in 1991?
Your answer should be compact. 1. What is the ratio of the Aid flow (current US$) in Sao Tome and Principe in 1989 to that in 1991?
Offer a very short reply. 0.34. What is the ratio of the Aid flow (current US$) in Sri Lanka in 1989 to that in 1991?
Make the answer very short. 0.72. What is the ratio of the Aid flow (current US$) in Djibouti in 1989 to that in 1992?
Give a very brief answer. 0.6. What is the ratio of the Aid flow (current US$) in French Polynesia in 1989 to that in 1992?
Your response must be concise. 0.82. What is the ratio of the Aid flow (current US$) of Sao Tome and Principe in 1989 to that in 1992?
Provide a short and direct response. 0.36. What is the ratio of the Aid flow (current US$) in Sri Lanka in 1989 to that in 1992?
Your answer should be very brief. 1.93. What is the ratio of the Aid flow (current US$) of Djibouti in 1989 to that in 1993?
Your answer should be very brief. 0.66. What is the ratio of the Aid flow (current US$) in French Polynesia in 1989 to that in 1993?
Your response must be concise. 1. What is the ratio of the Aid flow (current US$) of Sao Tome and Principe in 1989 to that in 1993?
Ensure brevity in your answer.  0.06. What is the ratio of the Aid flow (current US$) in Sri Lanka in 1989 to that in 1993?
Ensure brevity in your answer.  1.26. What is the ratio of the Aid flow (current US$) in Djibouti in 1989 to that in 1994?
Make the answer very short. 0.21. What is the ratio of the Aid flow (current US$) in French Polynesia in 1989 to that in 1994?
Make the answer very short. 2.33. What is the ratio of the Aid flow (current US$) of Sao Tome and Principe in 1989 to that in 1994?
Give a very brief answer. 0.12. What is the ratio of the Aid flow (current US$) in Sri Lanka in 1989 to that in 1994?
Offer a terse response. 0.87. What is the ratio of the Aid flow (current US$) in Djibouti in 1990 to that in 1991?
Provide a succinct answer. 0.58. What is the ratio of the Aid flow (current US$) of Sao Tome and Principe in 1990 to that in 1991?
Offer a very short reply. 2.31. What is the ratio of the Aid flow (current US$) of Sri Lanka in 1990 to that in 1991?
Offer a very short reply. 0.69. What is the ratio of the Aid flow (current US$) in Djibouti in 1990 to that in 1992?
Your response must be concise. 0.93. What is the ratio of the Aid flow (current US$) in French Polynesia in 1990 to that in 1992?
Give a very brief answer. 0.59. What is the ratio of the Aid flow (current US$) in Sao Tome and Principe in 1990 to that in 1992?
Your response must be concise. 2.47. What is the ratio of the Aid flow (current US$) in Sri Lanka in 1990 to that in 1992?
Give a very brief answer. 1.83. What is the ratio of the Aid flow (current US$) of Djibouti in 1990 to that in 1993?
Offer a terse response. 1.02. What is the ratio of the Aid flow (current US$) of Sao Tome and Principe in 1990 to that in 1993?
Offer a terse response. 0.41. What is the ratio of the Aid flow (current US$) in Sri Lanka in 1990 to that in 1993?
Keep it short and to the point. 1.2. What is the ratio of the Aid flow (current US$) of Djibouti in 1990 to that in 1994?
Make the answer very short. 0.32. What is the ratio of the Aid flow (current US$) in French Polynesia in 1990 to that in 1994?
Your answer should be very brief. 1.67. What is the ratio of the Aid flow (current US$) in Sao Tome and Principe in 1990 to that in 1994?
Ensure brevity in your answer.  0.8. What is the ratio of the Aid flow (current US$) in Sri Lanka in 1990 to that in 1994?
Your response must be concise. 0.82. What is the ratio of the Aid flow (current US$) of Djibouti in 1991 to that in 1992?
Give a very brief answer. 1.59. What is the ratio of the Aid flow (current US$) in French Polynesia in 1991 to that in 1992?
Make the answer very short. 0.82. What is the ratio of the Aid flow (current US$) in Sao Tome and Principe in 1991 to that in 1992?
Your response must be concise. 1.07. What is the ratio of the Aid flow (current US$) in Sri Lanka in 1991 to that in 1992?
Give a very brief answer. 2.67. What is the ratio of the Aid flow (current US$) of Djibouti in 1991 to that in 1993?
Your answer should be compact. 1.76. What is the ratio of the Aid flow (current US$) in French Polynesia in 1991 to that in 1993?
Keep it short and to the point. 1. What is the ratio of the Aid flow (current US$) in Sao Tome and Principe in 1991 to that in 1993?
Provide a short and direct response. 0.18. What is the ratio of the Aid flow (current US$) in Sri Lanka in 1991 to that in 1993?
Provide a short and direct response. 1.74. What is the ratio of the Aid flow (current US$) in Djibouti in 1991 to that in 1994?
Ensure brevity in your answer.  0.56. What is the ratio of the Aid flow (current US$) in French Polynesia in 1991 to that in 1994?
Offer a terse response. 2.33. What is the ratio of the Aid flow (current US$) in Sao Tome and Principe in 1991 to that in 1994?
Your answer should be compact. 0.35. What is the ratio of the Aid flow (current US$) of Sri Lanka in 1991 to that in 1994?
Make the answer very short. 1.2. What is the ratio of the Aid flow (current US$) in Djibouti in 1992 to that in 1993?
Make the answer very short. 1.11. What is the ratio of the Aid flow (current US$) in French Polynesia in 1992 to that in 1993?
Offer a very short reply. 1.21. What is the ratio of the Aid flow (current US$) in Sao Tome and Principe in 1992 to that in 1993?
Provide a short and direct response. 0.16. What is the ratio of the Aid flow (current US$) of Sri Lanka in 1992 to that in 1993?
Ensure brevity in your answer.  0.65. What is the ratio of the Aid flow (current US$) of Djibouti in 1992 to that in 1994?
Your answer should be very brief. 0.35. What is the ratio of the Aid flow (current US$) in French Polynesia in 1992 to that in 1994?
Provide a short and direct response. 2.83. What is the ratio of the Aid flow (current US$) in Sao Tome and Principe in 1992 to that in 1994?
Your answer should be compact. 0.32. What is the ratio of the Aid flow (current US$) in Sri Lanka in 1992 to that in 1994?
Keep it short and to the point. 0.45. What is the ratio of the Aid flow (current US$) in Djibouti in 1993 to that in 1994?
Keep it short and to the point. 0.32. What is the ratio of the Aid flow (current US$) in French Polynesia in 1993 to that in 1994?
Offer a terse response. 2.33. What is the ratio of the Aid flow (current US$) in Sao Tome and Principe in 1993 to that in 1994?
Your answer should be compact. 1.97. What is the ratio of the Aid flow (current US$) in Sri Lanka in 1993 to that in 1994?
Give a very brief answer. 0.69. What is the difference between the highest and the second highest Aid flow (current US$) in Djibouti?
Provide a succinct answer. 7.97e+06. What is the difference between the highest and the second highest Aid flow (current US$) in French Polynesia?
Give a very brief answer. 3.00e+04. What is the difference between the highest and the second highest Aid flow (current US$) of Sao Tome and Principe?
Provide a succinct answer. 3.09e+06. What is the difference between the highest and the second highest Aid flow (current US$) of Sri Lanka?
Provide a short and direct response. 4.24e+07. What is the difference between the highest and the lowest Aid flow (current US$) in Djibouti?
Offer a terse response. 1.44e+07. What is the difference between the highest and the lowest Aid flow (current US$) of Sao Tome and Principe?
Your answer should be compact. 5.89e+06. What is the difference between the highest and the lowest Aid flow (current US$) of Sri Lanka?
Give a very brief answer. 1.60e+08. 